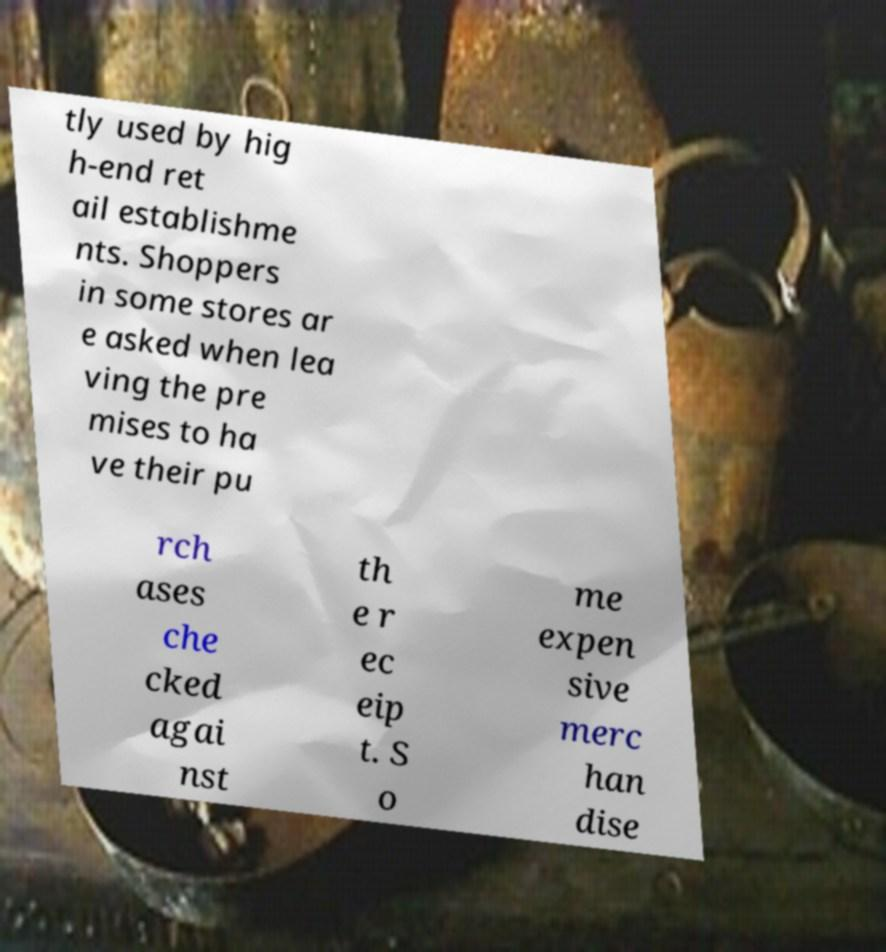Could you assist in decoding the text presented in this image and type it out clearly? tly used by hig h-end ret ail establishme nts. Shoppers in some stores ar e asked when lea ving the pre mises to ha ve their pu rch ases che cked agai nst th e r ec eip t. S o me expen sive merc han dise 